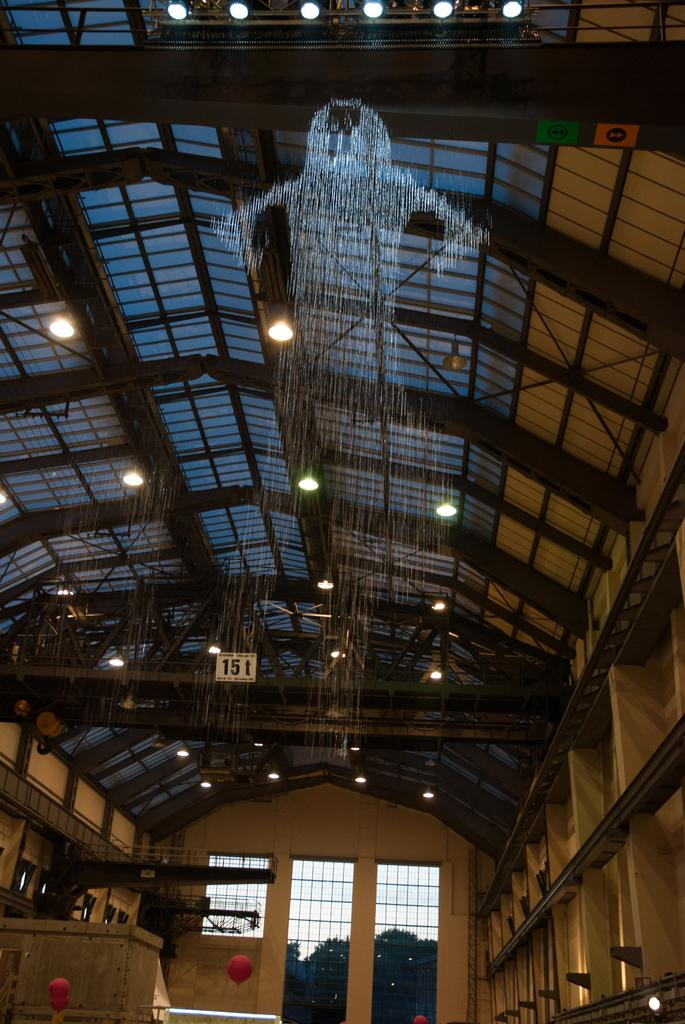What is the main subject in the center of the image? There is a water fountain in the center of the image. What can be seen in the background of the image? In the background of the image, there are pillars, lights, windows, trees, the sky, and a wall. Can you describe the architectural features in the background? The background features pillars and a wall. What type of natural elements are visible in the background? Trees and the sky are visible in the background. How many hens are sitting on the water fountain in the image? There are no hens present in the image; the main subject is a water fountain. What is the profit margin of the water fountain in the image? The image does not provide information about the profit margin of the water fountain, as it is not a commercial entity. 